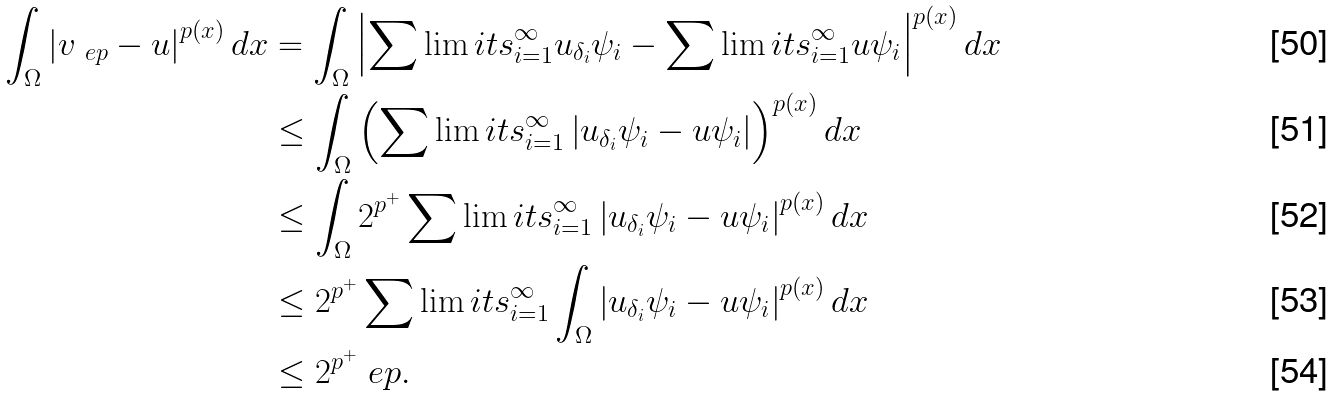Convert formula to latex. <formula><loc_0><loc_0><loc_500><loc_500>\int _ { \Omega } \left | v _ { \ e p } - u \right | ^ { p ( x ) } d x & = \int _ { \Omega } \left | \sum \lim i t s _ { i = 1 } ^ { \infty } u _ { \delta _ { i } } \psi _ { i } - \sum \lim i t s _ { i = 1 } ^ { \infty } u \psi _ { i } \right | ^ { p ( x ) } d x \\ & \leq \int _ { \Omega } \left ( \sum \lim i t s _ { i = 1 } ^ { \infty } \left | u _ { \delta _ { i } } \psi _ { i } - u \psi _ { i } \right | \right ) ^ { p ( x ) } d x \\ & \leq \int _ { \Omega } 2 ^ { p ^ { + } } \sum \lim i t s _ { i = 1 } ^ { \infty } \left | u _ { \delta _ { i } } \psi _ { i } - u \psi _ { i } \right | ^ { p ( x ) } d x \\ & \leq 2 ^ { p ^ { + } } \sum \lim i t s _ { i = 1 } ^ { \infty } \int _ { \Omega } \left | u _ { \delta _ { i } } \psi _ { i } - u \psi _ { i } \right | ^ { p ( x ) } d x \\ & \leq 2 ^ { p ^ { + } } \ e p .</formula> 